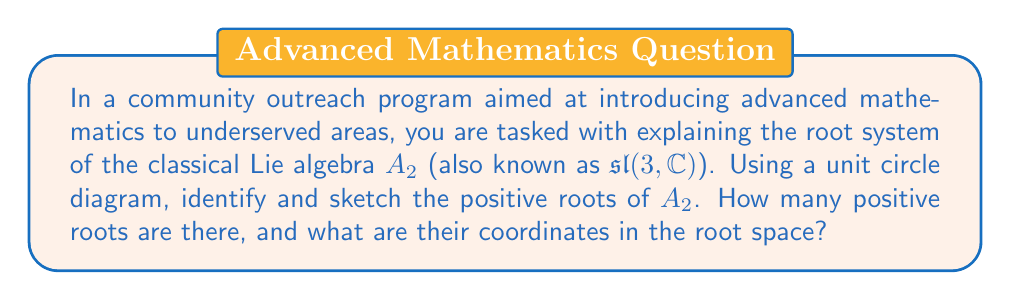Help me with this question. Let's approach this step-by-step:

1) The Lie algebra $A_2$ corresponds to the special linear group $SL(3,\mathbb{C})$. Its root system is two-dimensional.

2) The positive roots of $A_2$ are:
   $\alpha_1 = (1, 0)$
   $\alpha_2 = (-\frac{1}{2}, \frac{\sqrt{3}}{2})$
   $\alpha_1 + \alpha_2 = (\frac{1}{2}, \frac{\sqrt{3}}{2})$

3) To visualize these roots, we can use a unit circle diagram:

[asy]
import geometry;

unitcircle();
draw((-1.5,0)--(1.5,0),arrow=Arrow(TeXHead));
draw((0,-1.5)--(0,1.5),arrow=Arrow(TeXHead));

draw((0,0)--(1,0),arrow=Arrow(TeXHead),red);
draw((0,0)--(-0.5,0.866),arrow=Arrow(TeXHead),blue);
draw((0,0)--(0.5,0.866),arrow=Arrow(TeXHead),green);

label("$\alpha_1$", (1,0), E, red);
label("$\alpha_2$", (-0.5,0.866), NW, blue);
label("$\alpha_1+\alpha_2$", (0.5,0.866), NE, green);

dot((1,0));
dot((-0.5,0.866));
dot((0.5,0.866));
[/asy]

4) In this diagram:
   - The red arrow represents $\alpha_1 = (1, 0)$
   - The blue arrow represents $\alpha_2 = (-\frac{1}{2}, \frac{\sqrt{3}}{2})$
   - The green arrow represents $\alpha_1 + \alpha_2 = (\frac{1}{2}, \frac{\sqrt{3}}{2})$

5) We can see that there are three positive roots in total.

6) The coordinates of these roots in the root space are:
   $\alpha_1: (1, 0)$
   $\alpha_2: (-\frac{1}{2}, \frac{\sqrt{3}}{2})$
   $\alpha_1 + \alpha_2: (\frac{1}{2}, \frac{\sqrt{3}}{2})$
Answer: There are 3 positive roots in the root system of $A_2$. Their coordinates in the root space are:
$$(1, 0), \quad (-\frac{1}{2}, \frac{\sqrt{3}}{2}), \quad (\frac{1}{2}, \frac{\sqrt{3}}{2})$$ 